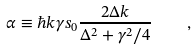Convert formula to latex. <formula><loc_0><loc_0><loc_500><loc_500>\alpha \equiv \hbar { k } \gamma s _ { 0 } \frac { 2 \Delta k } { \Delta ^ { 2 } + \gamma ^ { 2 } / 4 } \quad ,</formula> 